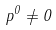<formula> <loc_0><loc_0><loc_500><loc_500>p ^ { 0 } \neq 0</formula> 